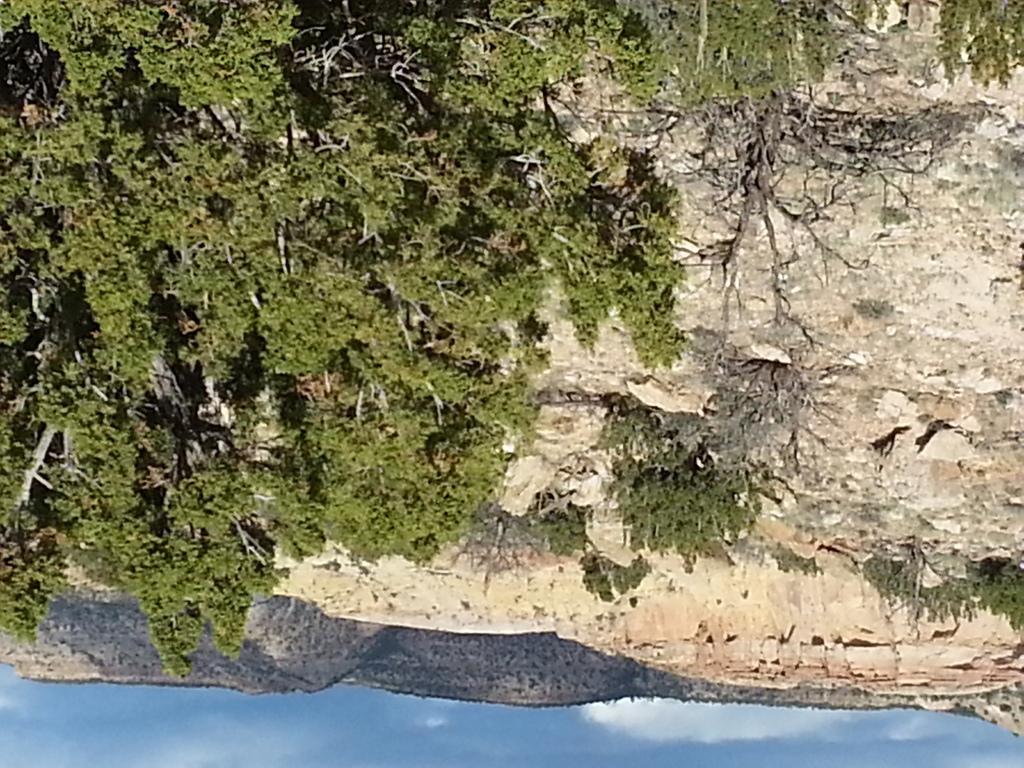Please provide a concise description of this image. In this picture I can see there are few mountains and there are few trees and the sky is clear. 